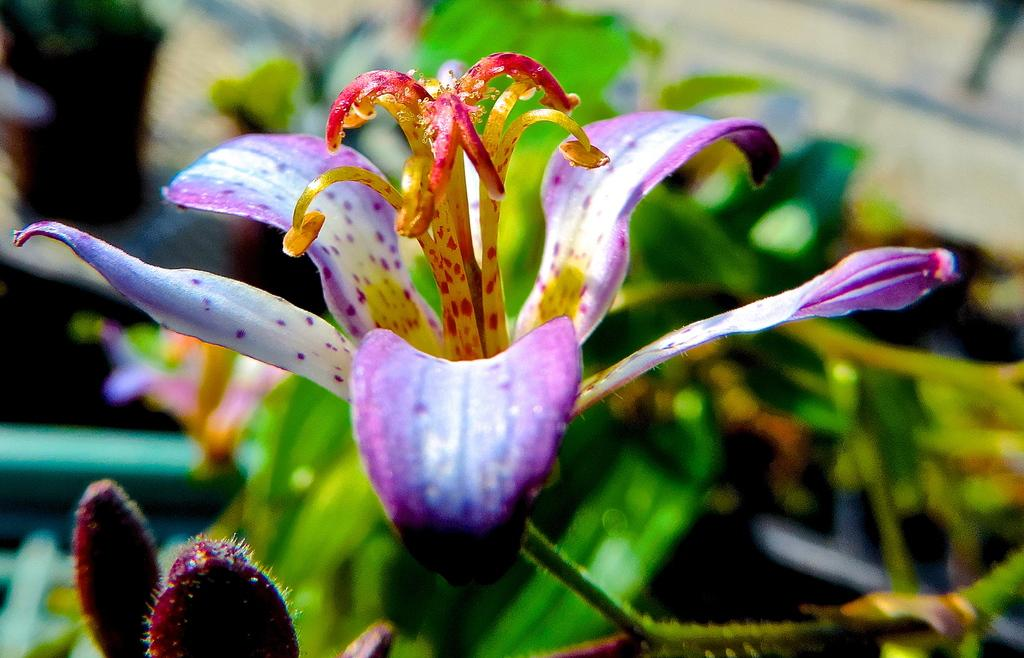What type of plant can be seen in the image? There is a flower in the image. Are there any other parts of the plant visible? Yes, there are buds in the image. What else can be seen in the image besides the flower and buds? There are plants in the image. Can you describe the background of the image? The background of the image is blurred. What is the reason for the yoke being present in the image? There is no yoke present in the image; it only features a flower, buds, plants, and a blurred background. 